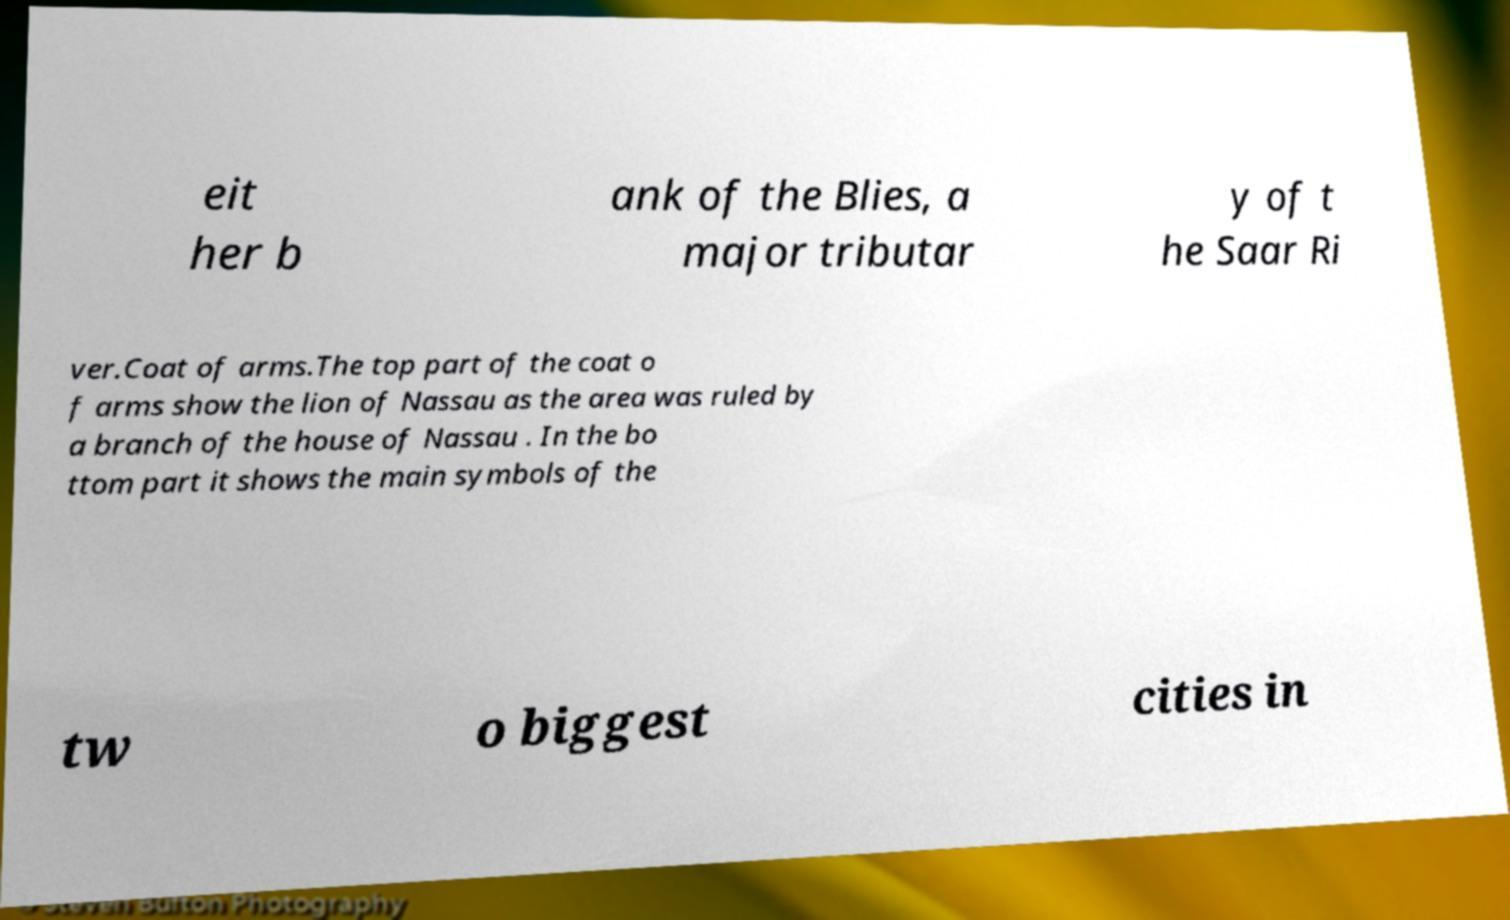Please read and relay the text visible in this image. What does it say? eit her b ank of the Blies, a major tributar y of t he Saar Ri ver.Coat of arms.The top part of the coat o f arms show the lion of Nassau as the area was ruled by a branch of the house of Nassau . In the bo ttom part it shows the main symbols of the tw o biggest cities in 